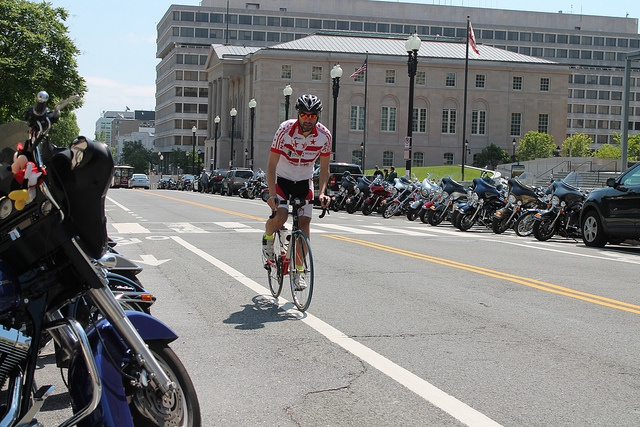Describe the objects in this image and their specific colors. I can see motorcycle in darkgreen, black, gray, darkgray, and navy tones, people in darkgreen, gray, black, darkgray, and maroon tones, car in darkgreen, black, gray, blue, and teal tones, bicycle in darkgreen, darkgray, black, gray, and maroon tones, and motorcycle in darkgreen, black, gray, darkgray, and navy tones in this image. 